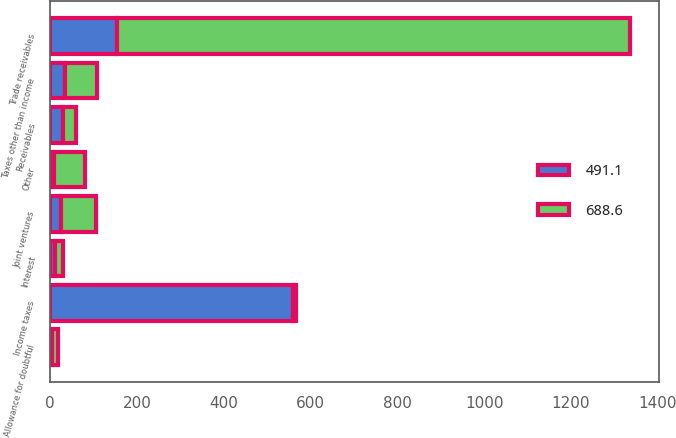Convert chart to OTSL. <chart><loc_0><loc_0><loc_500><loc_500><stacked_bar_chart><ecel><fcel>Receivables<fcel>Trade receivables<fcel>Income taxes<fcel>Taxes other than income<fcel>Joint ventures<fcel>Interest<fcel>Other<fcel>Allowance for doubtful<nl><fcel>491.1<fcel>30.1<fcel>154.9<fcel>560.2<fcel>34.9<fcel>25.3<fcel>10.9<fcel>9.2<fcel>3.8<nl><fcel>688.6<fcel>30.1<fcel>1180.1<fcel>6.6<fcel>72.3<fcel>79.4<fcel>18.9<fcel>70.2<fcel>14.4<nl></chart> 